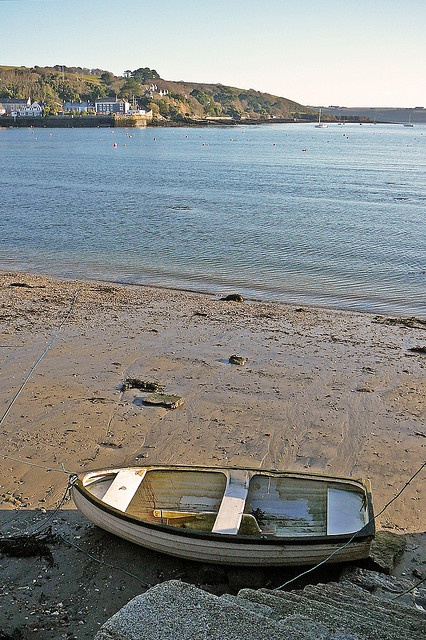Describe the objects in this image and their specific colors. I can see a boat in lightblue, gray, black, ivory, and darkgray tones in this image. 